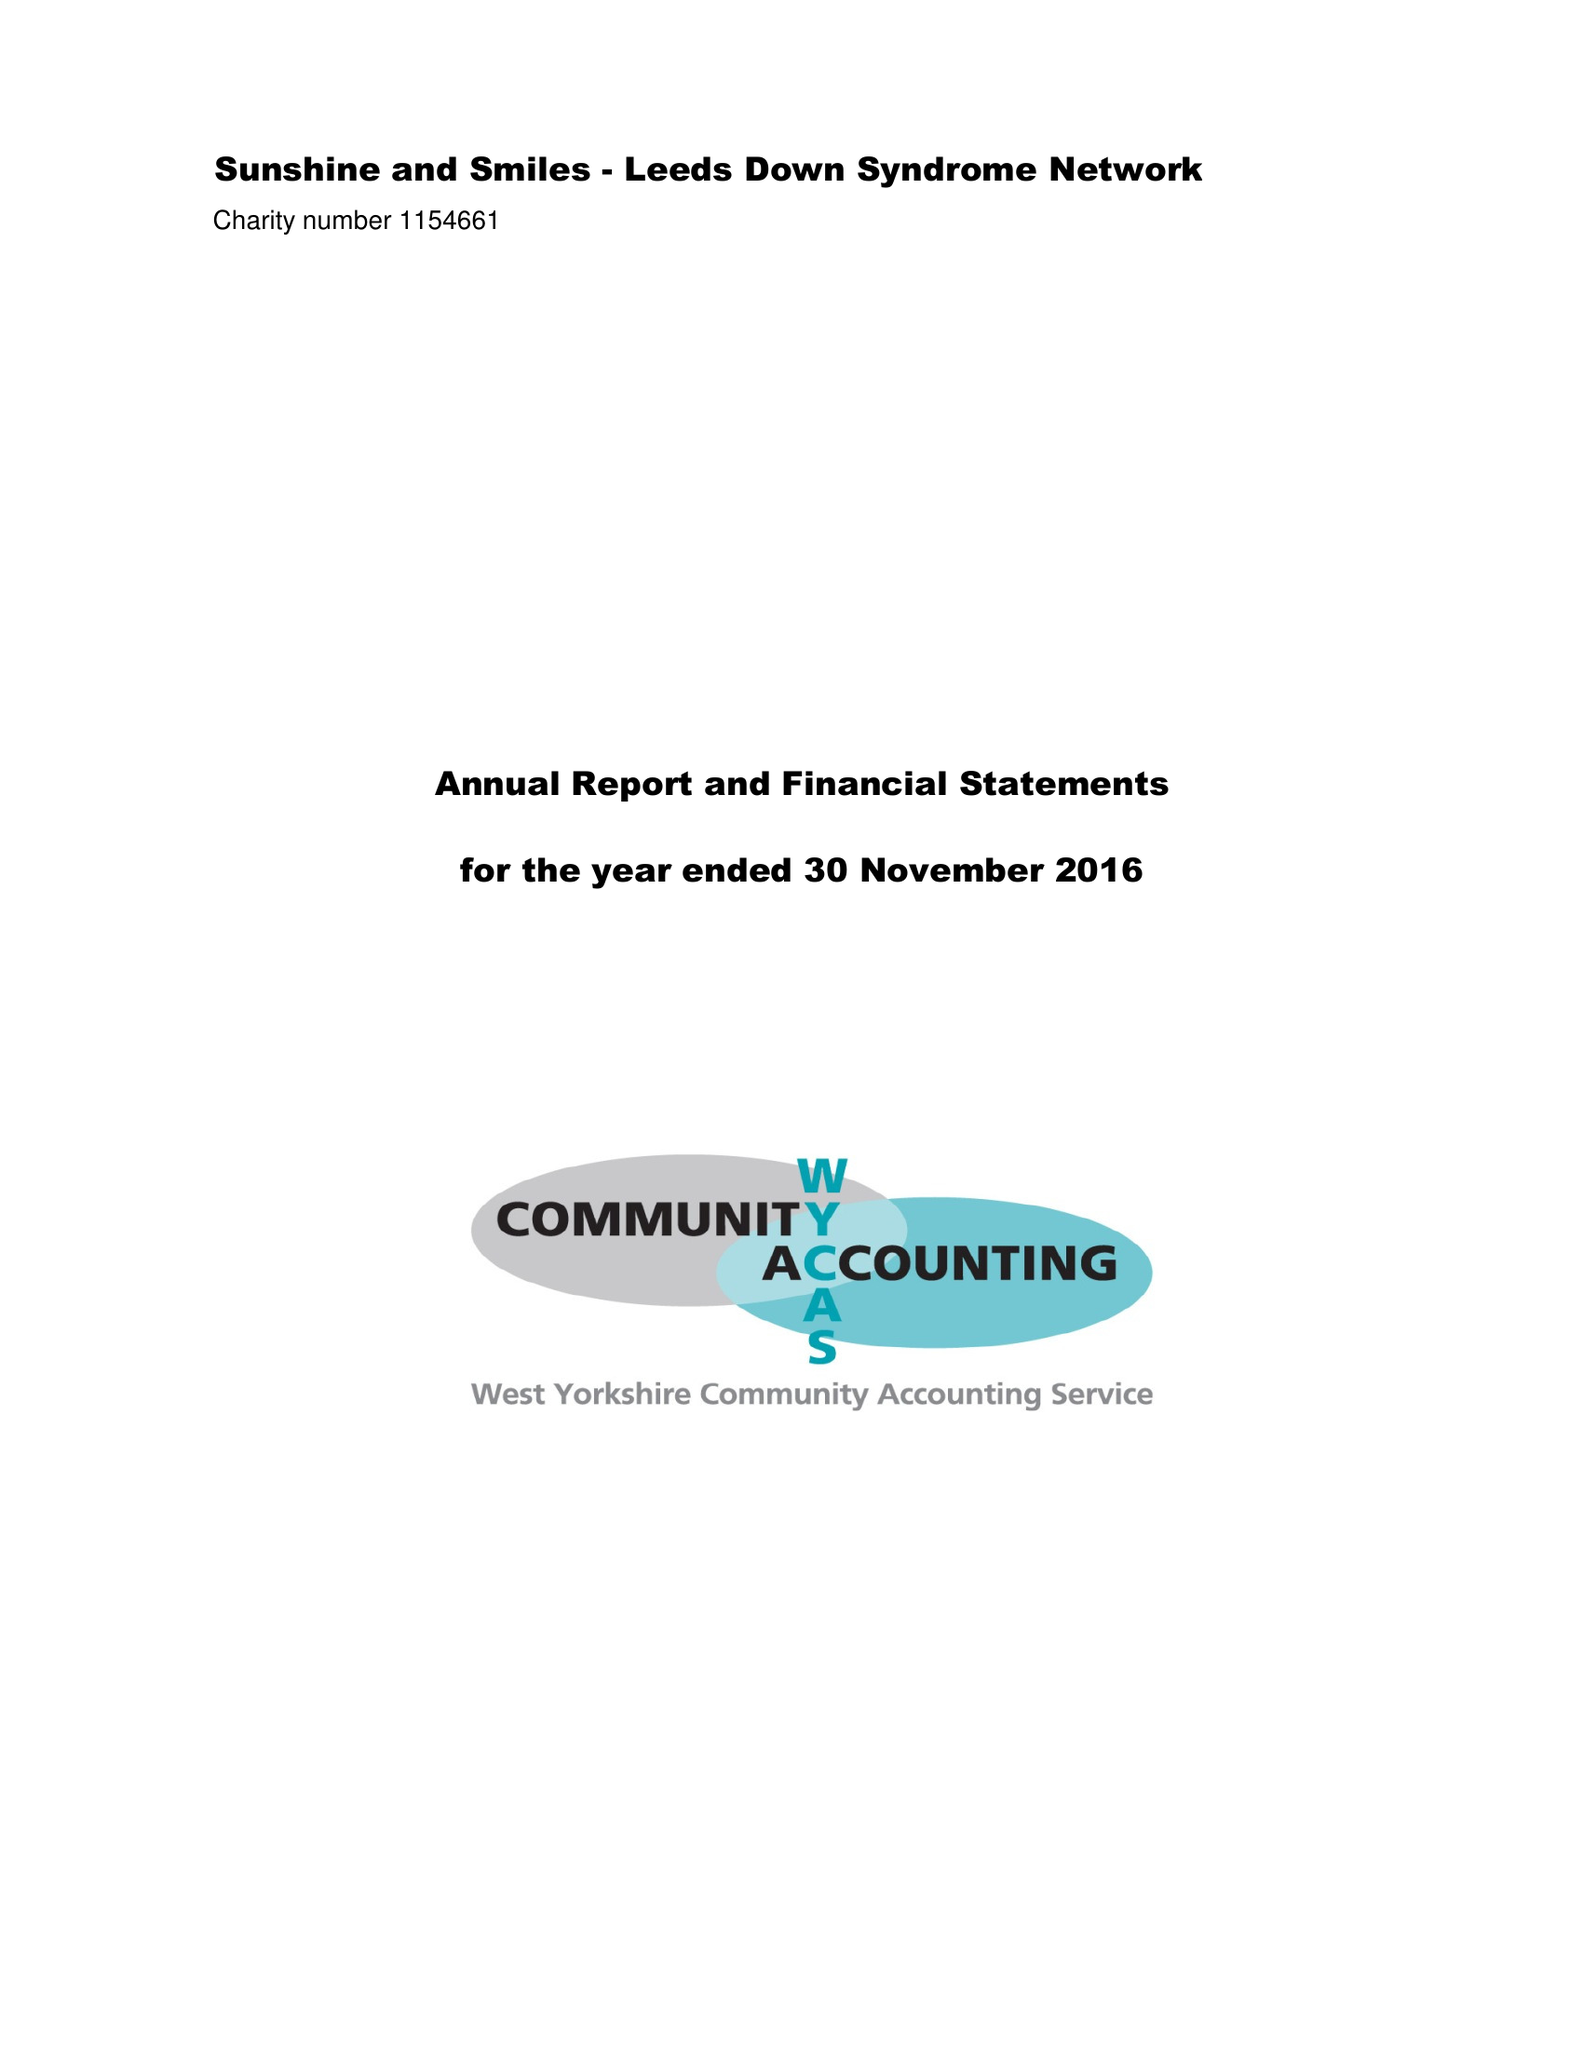What is the value for the charity_name?
Answer the question using a single word or phrase. Sunshine and Smiles - Leeds Down Syndrome Network 